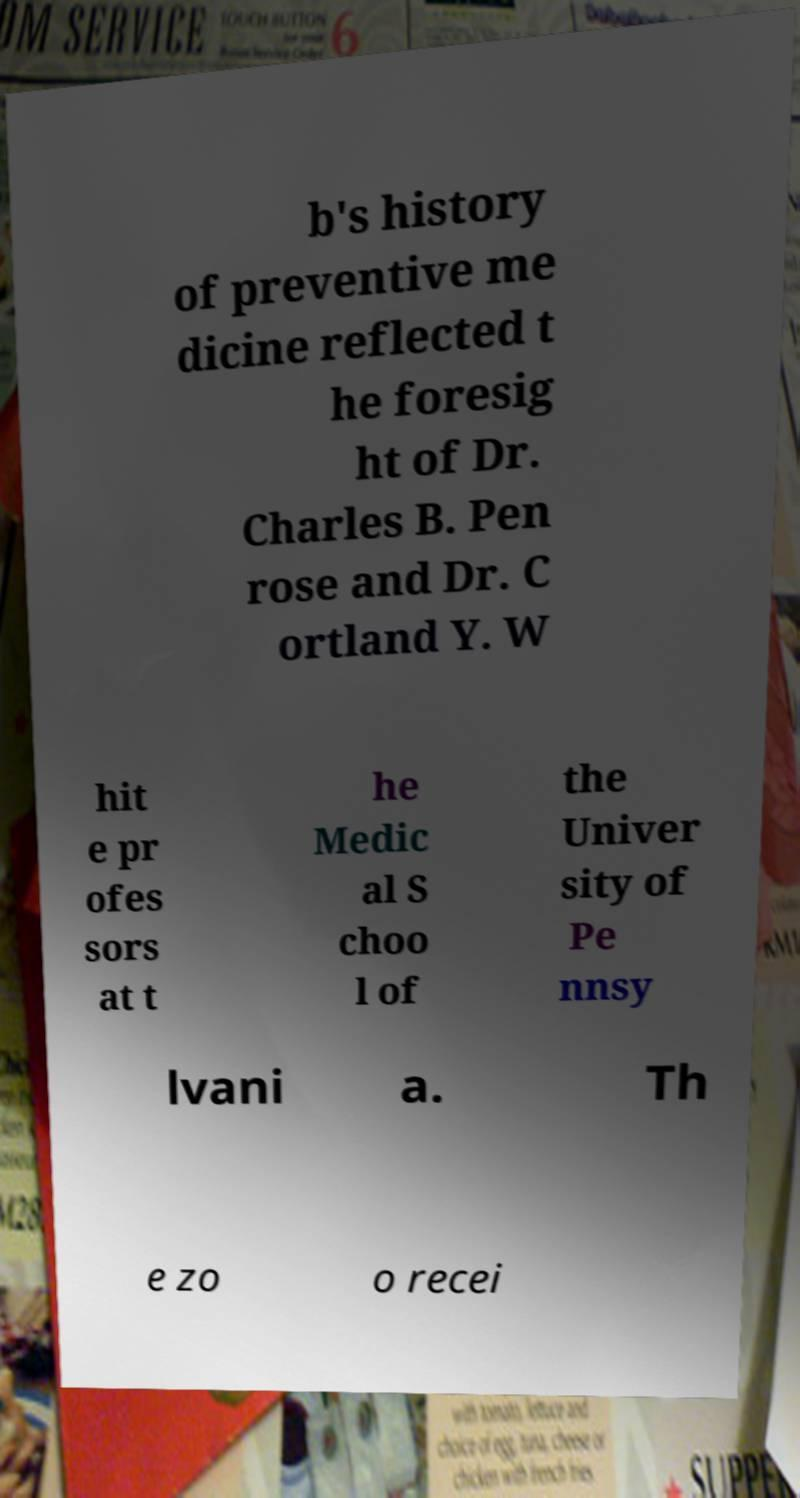Could you extract and type out the text from this image? b's history of preventive me dicine reflected t he foresig ht of Dr. Charles B. Pen rose and Dr. C ortland Y. W hit e pr ofes sors at t he Medic al S choo l of the Univer sity of Pe nnsy lvani a. Th e zo o recei 